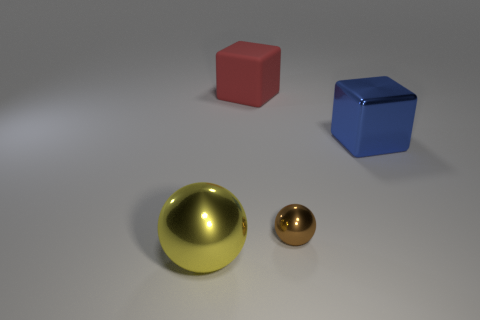Subtract 2 spheres. How many spheres are left? 0 Add 4 tiny purple rubber spheres. How many objects exist? 8 Subtract all blue cubes. How many cubes are left? 1 Subtract all large yellow metal balls. Subtract all large blue metal objects. How many objects are left? 2 Add 4 yellow metal spheres. How many yellow metal spheres are left? 5 Add 4 large metallic cubes. How many large metallic cubes exist? 5 Subtract 0 purple balls. How many objects are left? 4 Subtract all green spheres. Subtract all cyan blocks. How many spheres are left? 2 Subtract all blue cylinders. How many red balls are left? 0 